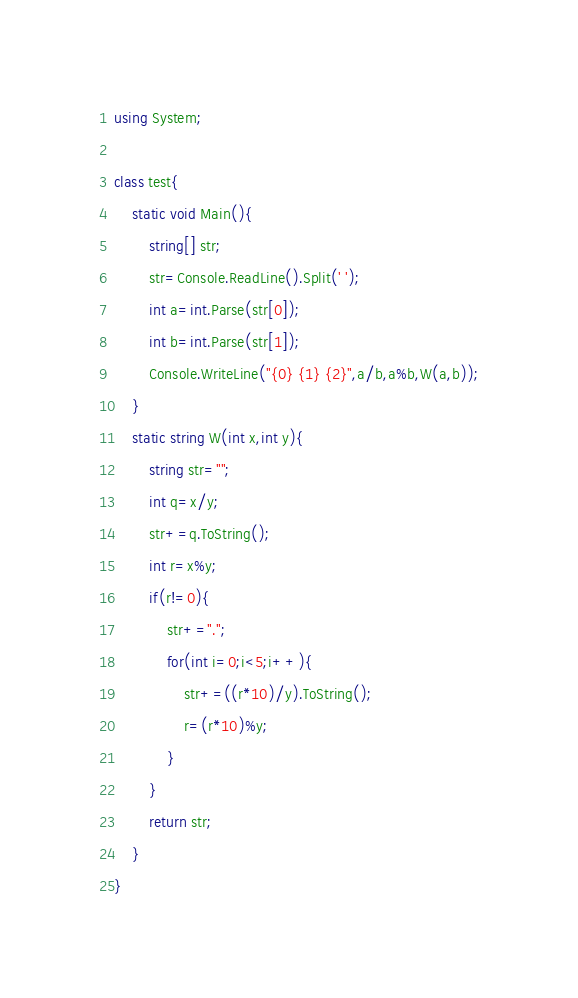<code> <loc_0><loc_0><loc_500><loc_500><_C#_>using System;

class test{
    static void Main(){
        string[] str;
        str=Console.ReadLine().Split(' ');
        int a=int.Parse(str[0]);
        int b=int.Parse(str[1]);
        Console.WriteLine("{0} {1} {2}",a/b,a%b,W(a,b));
    }
    static string W(int x,int y){
        string str="";
        int q=x/y;
        str+=q.ToString();
        int r=x%y;
        if(r!=0){
            str+=".";
            for(int i=0;i<5;i++){
                str+=((r*10)/y).ToString();
                r=(r*10)%y;
            }
        }
        return str;
    }
}
</code> 